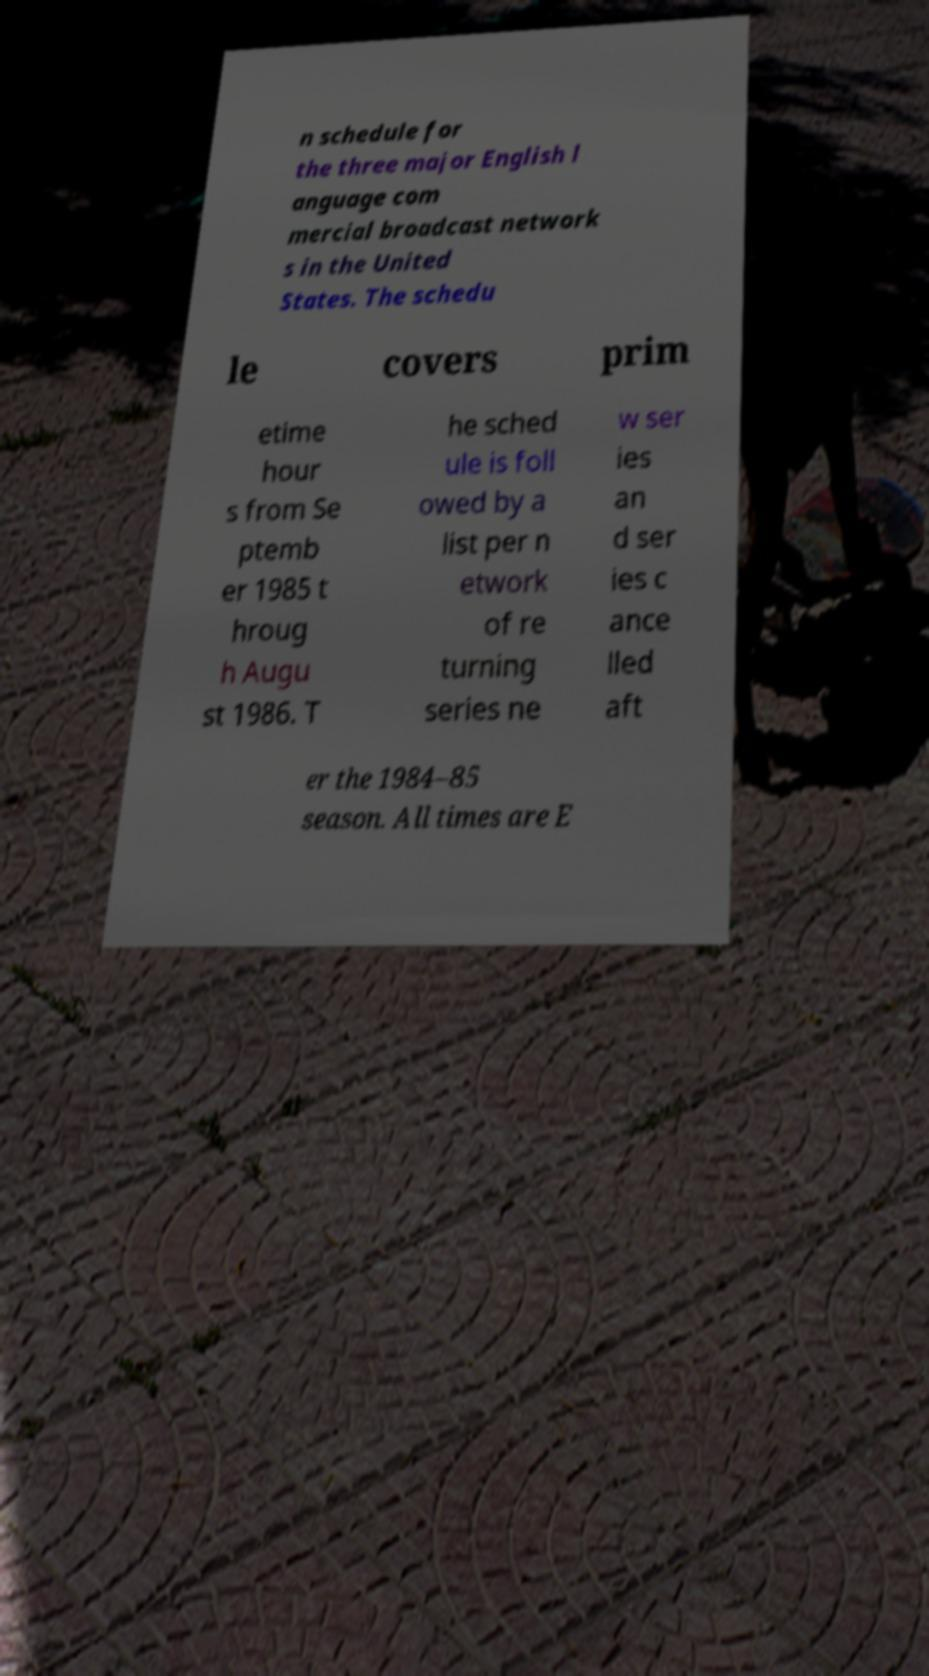Could you assist in decoding the text presented in this image and type it out clearly? n schedule for the three major English l anguage com mercial broadcast network s in the United States. The schedu le covers prim etime hour s from Se ptemb er 1985 t hroug h Augu st 1986. T he sched ule is foll owed by a list per n etwork of re turning series ne w ser ies an d ser ies c ance lled aft er the 1984–85 season. All times are E 